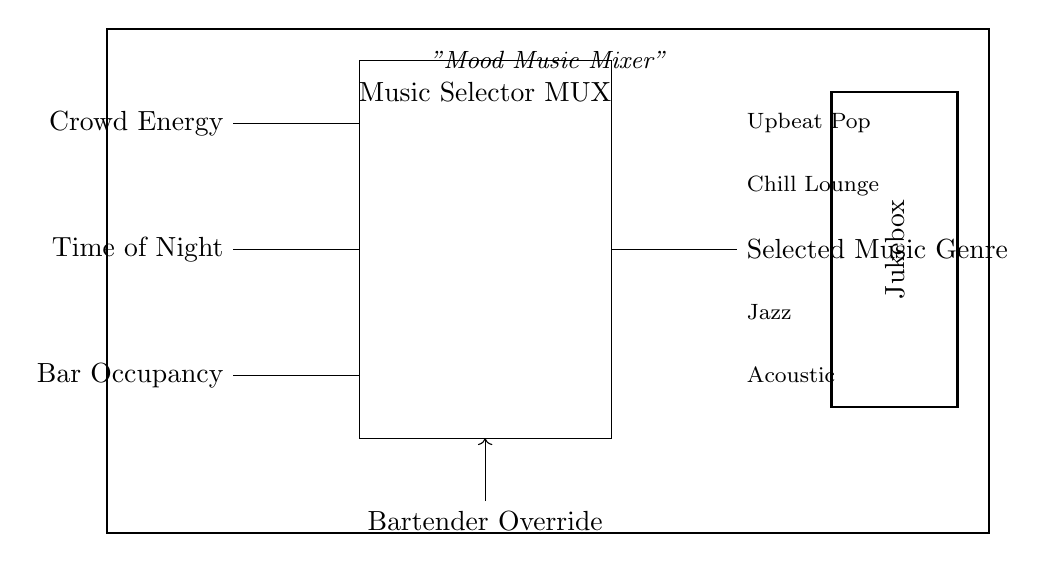What are the inputs to the multiplexer? The multiplexer has three inputs: Crowd Energy, Time of Night, and Bar Occupancy. Each input influences the music selection.
Answer: Crowd Energy, Time of Night, Bar Occupancy What does the Bartender Override control? The Bartender Override serves as a control input allowing the bartender to manually select the music genre, overriding the automatic selection based on crowd mood.
Answer: Music selection How many music genres can be selected by the multiplexer? The multiplexer can select from four different music genres: Upbeat Pop, Chill Lounge, Jazz, and Acoustic.
Answer: Four What is the purpose of the Music Selector MUX? The purpose of the Music Selector MUX is to automatically select the appropriate background music based on inputs regarding crowd mood, energy, time, and occupancy levels.
Answer: Automatic music selection Which music genre is typically associated with low crowd energy? From the options provided, Jazz is likely associated with low crowd energy, as it tends to create a relaxed atmosphere.
Answer: Jazz If the Crowd Energy is high, which music genre is most likely to be selected? When Crowd Energy is high, the Music Selector MUX would most likely select Upbeat Pop, which aligns with an energetic crowd.
Answer: Upbeat Pop What type of circuit component is consistent with the functionality of the Music Selector MUX? The Music Selector MUX functions as a combinational logic circuit component, as it outputs a selection based on multiple input variables simultaneously.
Answer: Combinational logic circuit 